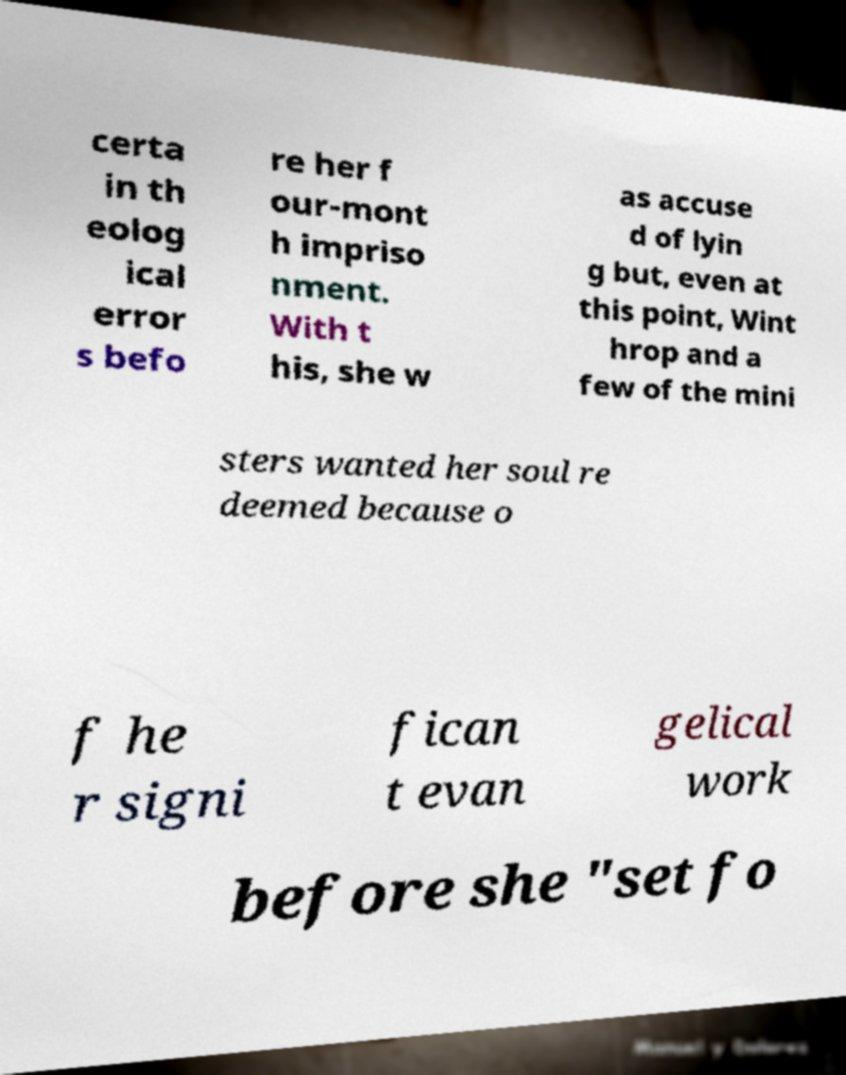Can you accurately transcribe the text from the provided image for me? certa in th eolog ical error s befo re her f our-mont h impriso nment. With t his, she w as accuse d of lyin g but, even at this point, Wint hrop and a few of the mini sters wanted her soul re deemed because o f he r signi fican t evan gelical work before she "set fo 